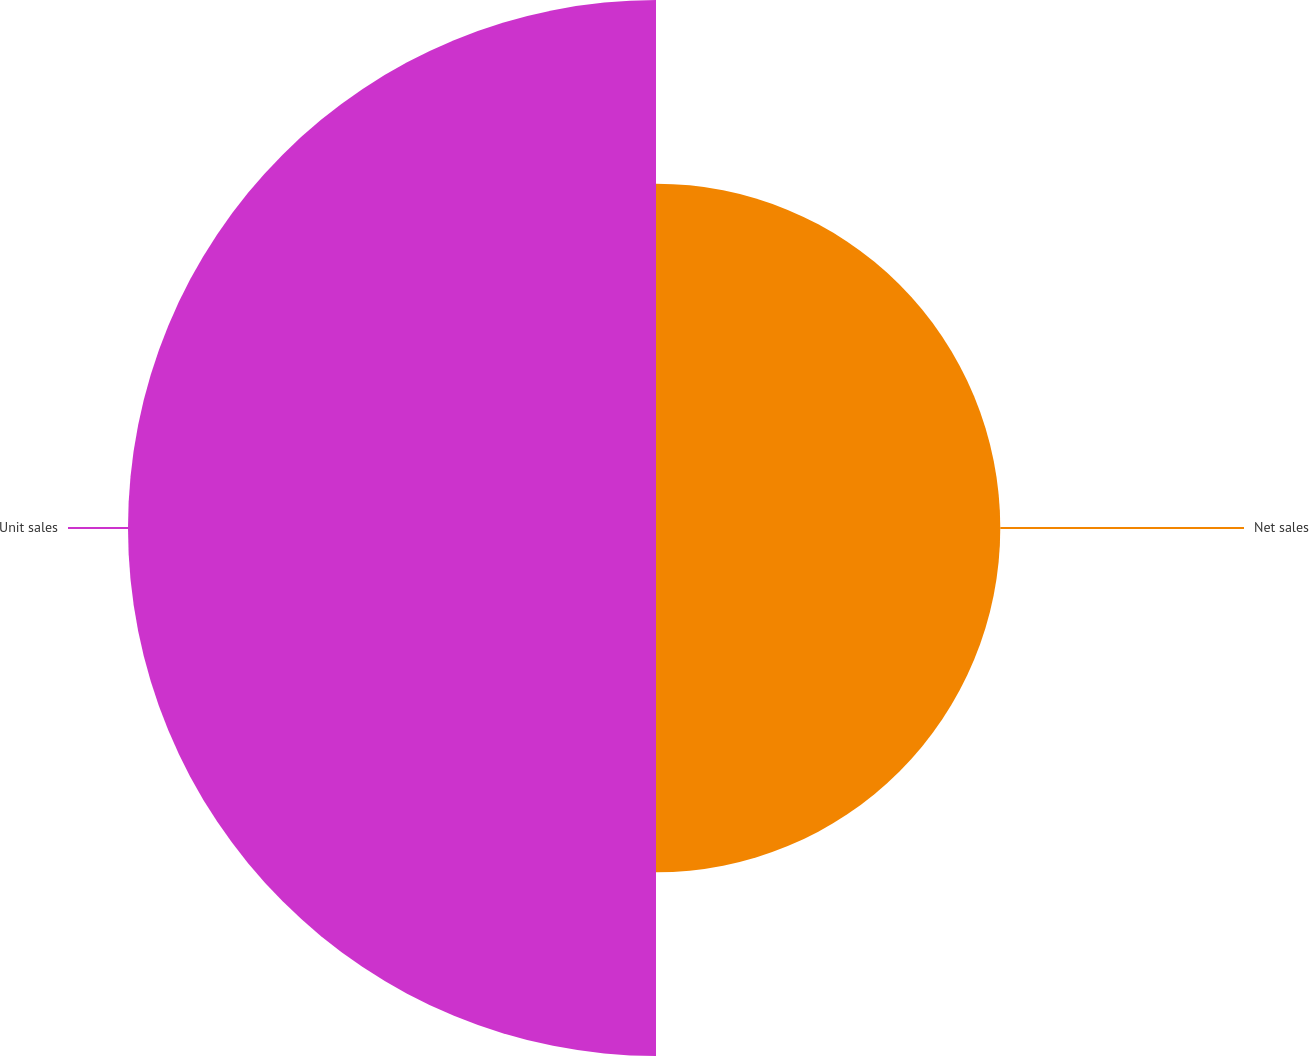Convert chart to OTSL. <chart><loc_0><loc_0><loc_500><loc_500><pie_chart><fcel>Net sales<fcel>Unit sales<nl><fcel>39.47%<fcel>60.53%<nl></chart> 